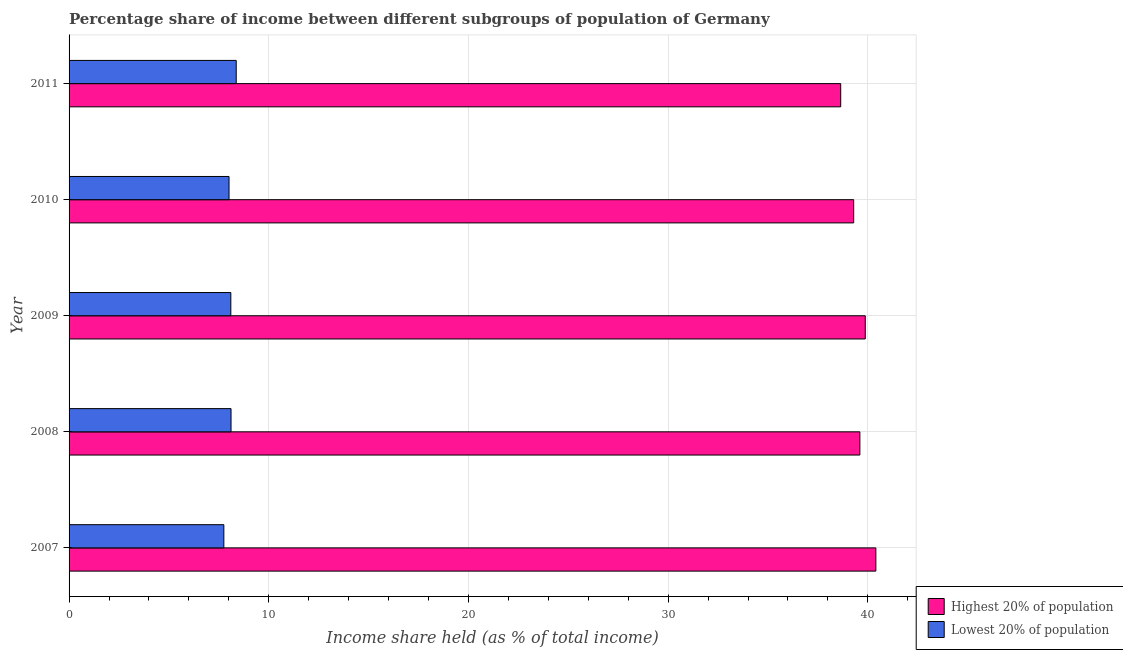How many different coloured bars are there?
Your response must be concise. 2. How many bars are there on the 3rd tick from the top?
Make the answer very short. 2. How many bars are there on the 3rd tick from the bottom?
Make the answer very short. 2. What is the label of the 5th group of bars from the top?
Offer a terse response. 2007. In how many cases, is the number of bars for a given year not equal to the number of legend labels?
Ensure brevity in your answer.  0. Across all years, what is the maximum income share held by lowest 20% of the population?
Keep it short and to the point. 8.37. Across all years, what is the minimum income share held by lowest 20% of the population?
Offer a very short reply. 7.75. In which year was the income share held by highest 20% of the population maximum?
Provide a succinct answer. 2007. In which year was the income share held by lowest 20% of the population minimum?
Your answer should be very brief. 2007. What is the total income share held by lowest 20% of the population in the graph?
Give a very brief answer. 40.34. What is the difference between the income share held by highest 20% of the population in 2007 and that in 2010?
Make the answer very short. 1.11. What is the difference between the income share held by lowest 20% of the population in 2011 and the income share held by highest 20% of the population in 2007?
Ensure brevity in your answer.  -32.03. What is the average income share held by lowest 20% of the population per year?
Give a very brief answer. 8.07. In the year 2007, what is the difference between the income share held by lowest 20% of the population and income share held by highest 20% of the population?
Offer a terse response. -32.65. In how many years, is the income share held by lowest 20% of the population greater than 32 %?
Provide a short and direct response. 0. Is the difference between the income share held by highest 20% of the population in 2007 and 2009 greater than the difference between the income share held by lowest 20% of the population in 2007 and 2009?
Your answer should be very brief. Yes. What is the difference between the highest and the second highest income share held by highest 20% of the population?
Ensure brevity in your answer.  0.53. What is the difference between the highest and the lowest income share held by lowest 20% of the population?
Offer a terse response. 0.62. In how many years, is the income share held by highest 20% of the population greater than the average income share held by highest 20% of the population taken over all years?
Give a very brief answer. 3. What does the 1st bar from the top in 2010 represents?
Offer a very short reply. Lowest 20% of population. What does the 2nd bar from the bottom in 2011 represents?
Keep it short and to the point. Lowest 20% of population. Are all the bars in the graph horizontal?
Keep it short and to the point. Yes. How many years are there in the graph?
Provide a succinct answer. 5. Does the graph contain any zero values?
Make the answer very short. No. Does the graph contain grids?
Offer a very short reply. Yes. Where does the legend appear in the graph?
Provide a short and direct response. Bottom right. How are the legend labels stacked?
Your answer should be very brief. Vertical. What is the title of the graph?
Your answer should be very brief. Percentage share of income between different subgroups of population of Germany. What is the label or title of the X-axis?
Make the answer very short. Income share held (as % of total income). What is the Income share held (as % of total income) in Highest 20% of population in 2007?
Keep it short and to the point. 40.4. What is the Income share held (as % of total income) of Lowest 20% of population in 2007?
Ensure brevity in your answer.  7.75. What is the Income share held (as % of total income) of Highest 20% of population in 2008?
Offer a very short reply. 39.6. What is the Income share held (as % of total income) of Lowest 20% of population in 2008?
Give a very brief answer. 8.11. What is the Income share held (as % of total income) of Highest 20% of population in 2009?
Ensure brevity in your answer.  39.87. What is the Income share held (as % of total income) in Highest 20% of population in 2010?
Keep it short and to the point. 39.29. What is the Income share held (as % of total income) in Lowest 20% of population in 2010?
Offer a very short reply. 8.01. What is the Income share held (as % of total income) of Highest 20% of population in 2011?
Give a very brief answer. 38.64. What is the Income share held (as % of total income) of Lowest 20% of population in 2011?
Offer a very short reply. 8.37. Across all years, what is the maximum Income share held (as % of total income) in Highest 20% of population?
Make the answer very short. 40.4. Across all years, what is the maximum Income share held (as % of total income) of Lowest 20% of population?
Make the answer very short. 8.37. Across all years, what is the minimum Income share held (as % of total income) of Highest 20% of population?
Ensure brevity in your answer.  38.64. Across all years, what is the minimum Income share held (as % of total income) in Lowest 20% of population?
Your response must be concise. 7.75. What is the total Income share held (as % of total income) in Highest 20% of population in the graph?
Ensure brevity in your answer.  197.8. What is the total Income share held (as % of total income) in Lowest 20% of population in the graph?
Your answer should be very brief. 40.34. What is the difference between the Income share held (as % of total income) of Highest 20% of population in 2007 and that in 2008?
Your response must be concise. 0.8. What is the difference between the Income share held (as % of total income) in Lowest 20% of population in 2007 and that in 2008?
Provide a succinct answer. -0.36. What is the difference between the Income share held (as % of total income) of Highest 20% of population in 2007 and that in 2009?
Give a very brief answer. 0.53. What is the difference between the Income share held (as % of total income) in Lowest 20% of population in 2007 and that in 2009?
Ensure brevity in your answer.  -0.35. What is the difference between the Income share held (as % of total income) of Highest 20% of population in 2007 and that in 2010?
Provide a short and direct response. 1.11. What is the difference between the Income share held (as % of total income) of Lowest 20% of population in 2007 and that in 2010?
Offer a terse response. -0.26. What is the difference between the Income share held (as % of total income) of Highest 20% of population in 2007 and that in 2011?
Your answer should be compact. 1.76. What is the difference between the Income share held (as % of total income) of Lowest 20% of population in 2007 and that in 2011?
Your answer should be very brief. -0.62. What is the difference between the Income share held (as % of total income) of Highest 20% of population in 2008 and that in 2009?
Offer a terse response. -0.27. What is the difference between the Income share held (as % of total income) in Lowest 20% of population in 2008 and that in 2009?
Your answer should be very brief. 0.01. What is the difference between the Income share held (as % of total income) of Highest 20% of population in 2008 and that in 2010?
Offer a very short reply. 0.31. What is the difference between the Income share held (as % of total income) of Lowest 20% of population in 2008 and that in 2010?
Make the answer very short. 0.1. What is the difference between the Income share held (as % of total income) in Highest 20% of population in 2008 and that in 2011?
Offer a terse response. 0.96. What is the difference between the Income share held (as % of total income) of Lowest 20% of population in 2008 and that in 2011?
Keep it short and to the point. -0.26. What is the difference between the Income share held (as % of total income) of Highest 20% of population in 2009 and that in 2010?
Your answer should be very brief. 0.58. What is the difference between the Income share held (as % of total income) in Lowest 20% of population in 2009 and that in 2010?
Your answer should be compact. 0.09. What is the difference between the Income share held (as % of total income) of Highest 20% of population in 2009 and that in 2011?
Make the answer very short. 1.23. What is the difference between the Income share held (as % of total income) in Lowest 20% of population in 2009 and that in 2011?
Your response must be concise. -0.27. What is the difference between the Income share held (as % of total income) of Highest 20% of population in 2010 and that in 2011?
Give a very brief answer. 0.65. What is the difference between the Income share held (as % of total income) in Lowest 20% of population in 2010 and that in 2011?
Keep it short and to the point. -0.36. What is the difference between the Income share held (as % of total income) of Highest 20% of population in 2007 and the Income share held (as % of total income) of Lowest 20% of population in 2008?
Keep it short and to the point. 32.29. What is the difference between the Income share held (as % of total income) in Highest 20% of population in 2007 and the Income share held (as % of total income) in Lowest 20% of population in 2009?
Your response must be concise. 32.3. What is the difference between the Income share held (as % of total income) in Highest 20% of population in 2007 and the Income share held (as % of total income) in Lowest 20% of population in 2010?
Ensure brevity in your answer.  32.39. What is the difference between the Income share held (as % of total income) of Highest 20% of population in 2007 and the Income share held (as % of total income) of Lowest 20% of population in 2011?
Keep it short and to the point. 32.03. What is the difference between the Income share held (as % of total income) in Highest 20% of population in 2008 and the Income share held (as % of total income) in Lowest 20% of population in 2009?
Ensure brevity in your answer.  31.5. What is the difference between the Income share held (as % of total income) in Highest 20% of population in 2008 and the Income share held (as % of total income) in Lowest 20% of population in 2010?
Keep it short and to the point. 31.59. What is the difference between the Income share held (as % of total income) of Highest 20% of population in 2008 and the Income share held (as % of total income) of Lowest 20% of population in 2011?
Your response must be concise. 31.23. What is the difference between the Income share held (as % of total income) of Highest 20% of population in 2009 and the Income share held (as % of total income) of Lowest 20% of population in 2010?
Your response must be concise. 31.86. What is the difference between the Income share held (as % of total income) of Highest 20% of population in 2009 and the Income share held (as % of total income) of Lowest 20% of population in 2011?
Your answer should be very brief. 31.5. What is the difference between the Income share held (as % of total income) of Highest 20% of population in 2010 and the Income share held (as % of total income) of Lowest 20% of population in 2011?
Ensure brevity in your answer.  30.92. What is the average Income share held (as % of total income) in Highest 20% of population per year?
Offer a very short reply. 39.56. What is the average Income share held (as % of total income) of Lowest 20% of population per year?
Provide a short and direct response. 8.07. In the year 2007, what is the difference between the Income share held (as % of total income) in Highest 20% of population and Income share held (as % of total income) in Lowest 20% of population?
Offer a very short reply. 32.65. In the year 2008, what is the difference between the Income share held (as % of total income) in Highest 20% of population and Income share held (as % of total income) in Lowest 20% of population?
Your response must be concise. 31.49. In the year 2009, what is the difference between the Income share held (as % of total income) of Highest 20% of population and Income share held (as % of total income) of Lowest 20% of population?
Your answer should be compact. 31.77. In the year 2010, what is the difference between the Income share held (as % of total income) in Highest 20% of population and Income share held (as % of total income) in Lowest 20% of population?
Give a very brief answer. 31.28. In the year 2011, what is the difference between the Income share held (as % of total income) in Highest 20% of population and Income share held (as % of total income) in Lowest 20% of population?
Your answer should be compact. 30.27. What is the ratio of the Income share held (as % of total income) in Highest 20% of population in 2007 to that in 2008?
Your response must be concise. 1.02. What is the ratio of the Income share held (as % of total income) of Lowest 20% of population in 2007 to that in 2008?
Offer a very short reply. 0.96. What is the ratio of the Income share held (as % of total income) in Highest 20% of population in 2007 to that in 2009?
Provide a succinct answer. 1.01. What is the ratio of the Income share held (as % of total income) in Lowest 20% of population in 2007 to that in 2009?
Provide a short and direct response. 0.96. What is the ratio of the Income share held (as % of total income) in Highest 20% of population in 2007 to that in 2010?
Your response must be concise. 1.03. What is the ratio of the Income share held (as % of total income) in Lowest 20% of population in 2007 to that in 2010?
Your response must be concise. 0.97. What is the ratio of the Income share held (as % of total income) in Highest 20% of population in 2007 to that in 2011?
Offer a very short reply. 1.05. What is the ratio of the Income share held (as % of total income) in Lowest 20% of population in 2007 to that in 2011?
Your answer should be very brief. 0.93. What is the ratio of the Income share held (as % of total income) in Lowest 20% of population in 2008 to that in 2009?
Keep it short and to the point. 1. What is the ratio of the Income share held (as % of total income) in Highest 20% of population in 2008 to that in 2010?
Provide a succinct answer. 1.01. What is the ratio of the Income share held (as % of total income) in Lowest 20% of population in 2008 to that in 2010?
Provide a short and direct response. 1.01. What is the ratio of the Income share held (as % of total income) of Highest 20% of population in 2008 to that in 2011?
Offer a terse response. 1.02. What is the ratio of the Income share held (as % of total income) of Lowest 20% of population in 2008 to that in 2011?
Your response must be concise. 0.97. What is the ratio of the Income share held (as % of total income) in Highest 20% of population in 2009 to that in 2010?
Make the answer very short. 1.01. What is the ratio of the Income share held (as % of total income) of Lowest 20% of population in 2009 to that in 2010?
Offer a terse response. 1.01. What is the ratio of the Income share held (as % of total income) of Highest 20% of population in 2009 to that in 2011?
Your answer should be compact. 1.03. What is the ratio of the Income share held (as % of total income) in Highest 20% of population in 2010 to that in 2011?
Offer a very short reply. 1.02. What is the difference between the highest and the second highest Income share held (as % of total income) in Highest 20% of population?
Your answer should be very brief. 0.53. What is the difference between the highest and the second highest Income share held (as % of total income) of Lowest 20% of population?
Offer a very short reply. 0.26. What is the difference between the highest and the lowest Income share held (as % of total income) in Highest 20% of population?
Provide a succinct answer. 1.76. What is the difference between the highest and the lowest Income share held (as % of total income) of Lowest 20% of population?
Offer a very short reply. 0.62. 